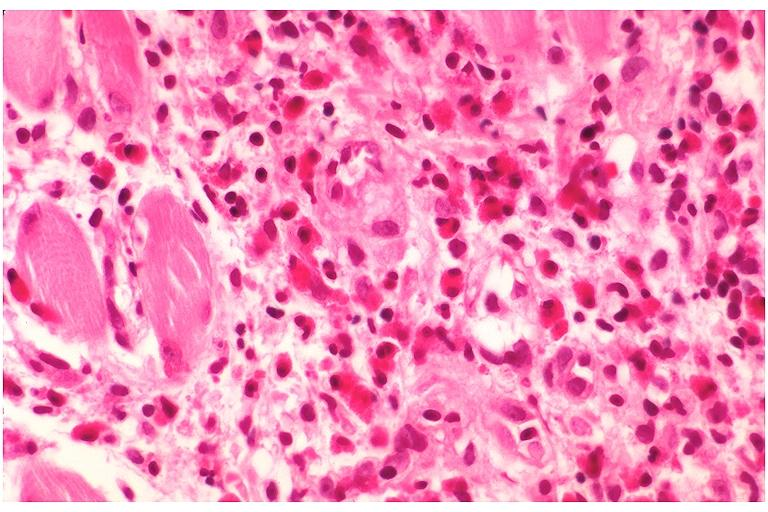s hand present?
Answer the question using a single word or phrase. No 